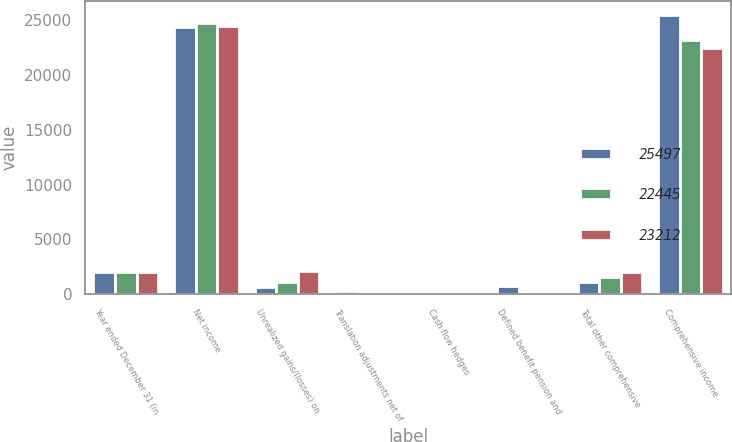Convert chart to OTSL. <chart><loc_0><loc_0><loc_500><loc_500><stacked_bar_chart><ecel><fcel>Year ended December 31 (in<fcel>Net income<fcel>Unrealized gains/(losses) on<fcel>Translation adjustments net of<fcel>Cash flow hedges<fcel>Defined benefit pension and<fcel>Total other comprehensive<fcel>Comprehensive income<nl><fcel>25497<fcel>2017<fcel>24441<fcel>640<fcel>306<fcel>176<fcel>738<fcel>1056<fcel>25497<nl><fcel>22445<fcel>2016<fcel>24733<fcel>1105<fcel>2<fcel>56<fcel>28<fcel>1521<fcel>23212<nl><fcel>23212<fcel>2015<fcel>24442<fcel>2144<fcel>15<fcel>51<fcel>111<fcel>1997<fcel>22445<nl></chart> 